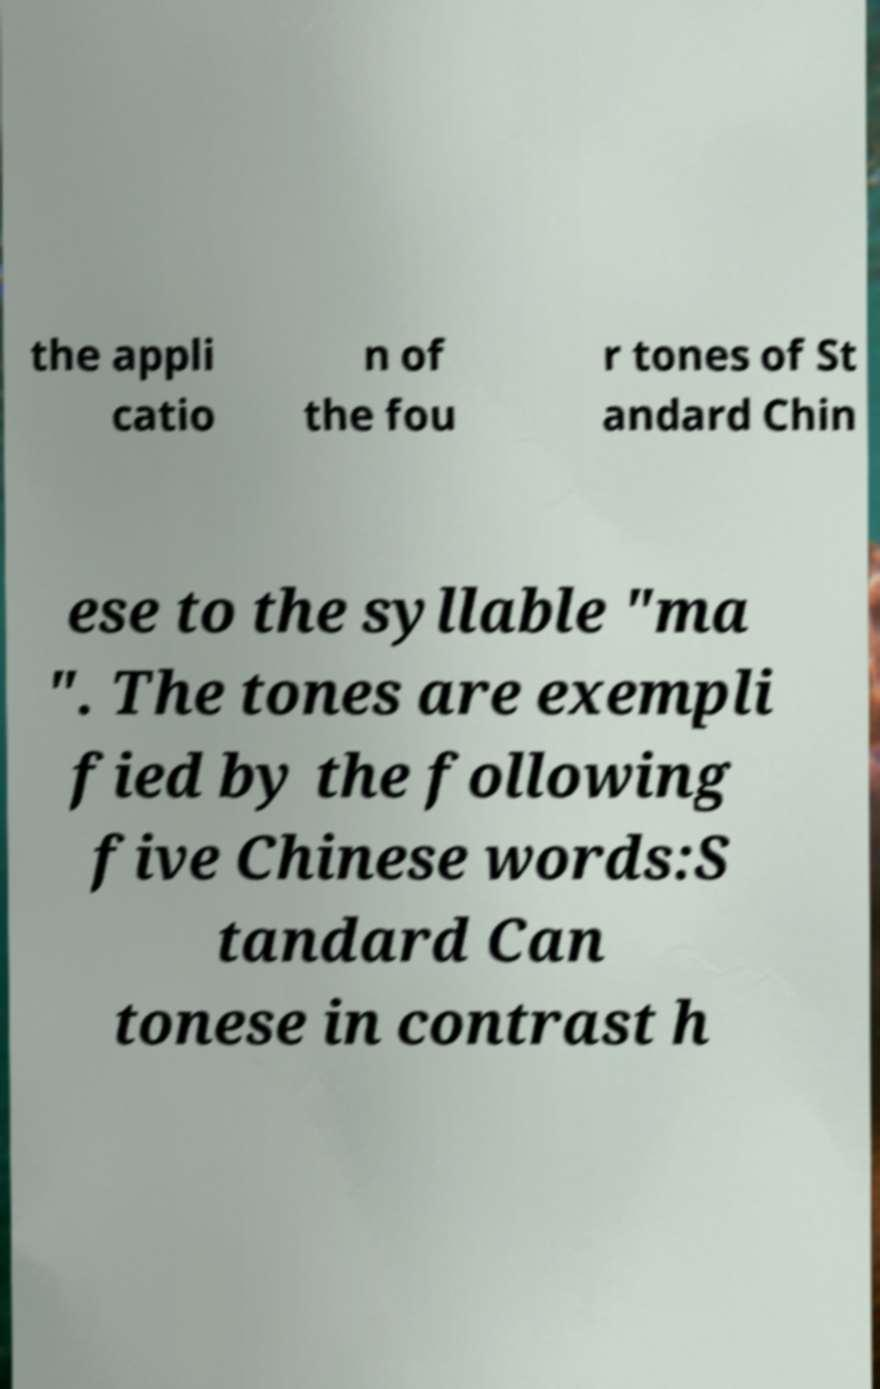For documentation purposes, I need the text within this image transcribed. Could you provide that? the appli catio n of the fou r tones of St andard Chin ese to the syllable "ma ". The tones are exempli fied by the following five Chinese words:S tandard Can tonese in contrast h 